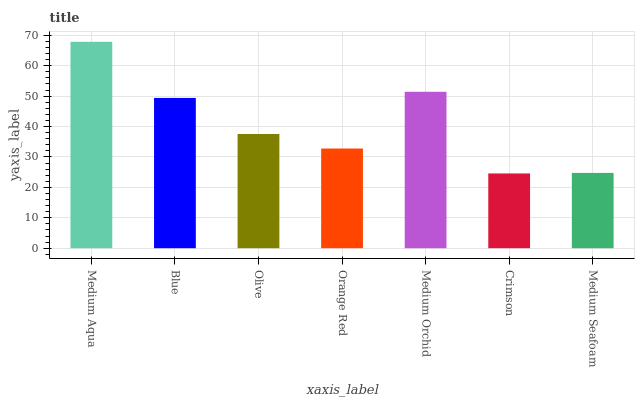Is Crimson the minimum?
Answer yes or no. Yes. Is Medium Aqua the maximum?
Answer yes or no. Yes. Is Blue the minimum?
Answer yes or no. No. Is Blue the maximum?
Answer yes or no. No. Is Medium Aqua greater than Blue?
Answer yes or no. Yes. Is Blue less than Medium Aqua?
Answer yes or no. Yes. Is Blue greater than Medium Aqua?
Answer yes or no. No. Is Medium Aqua less than Blue?
Answer yes or no. No. Is Olive the high median?
Answer yes or no. Yes. Is Olive the low median?
Answer yes or no. Yes. Is Medium Seafoam the high median?
Answer yes or no. No. Is Medium Aqua the low median?
Answer yes or no. No. 